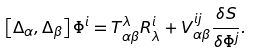<formula> <loc_0><loc_0><loc_500><loc_500>\left [ \Delta _ { \alpha } , \Delta _ { \beta } \right ] \Phi ^ { i } = T _ { \alpha \beta } ^ { \lambda } R _ { \lambda } ^ { i } + V _ { \alpha \beta } ^ { i j } \frac { \delta S } { \delta \Phi ^ { j } } .</formula> 